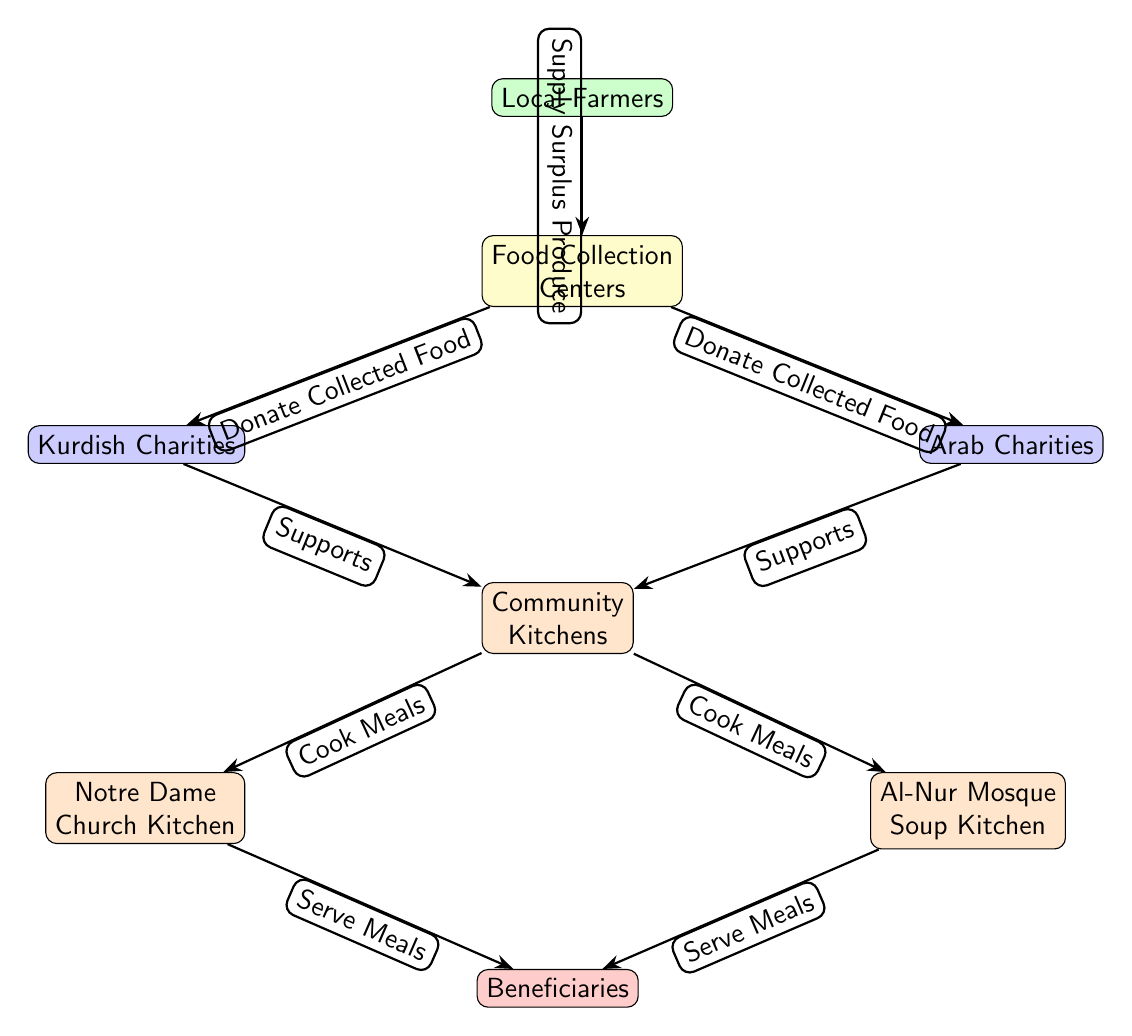What is the top node in the diagram? The top node is labeled "Local Farmers," indicating that they are the initial source of the food donation network.
Answer: Local Farmers How many community kitchens are listed in the diagram? The diagram includes two community kitchens: "Notre Dame Church Kitchen" and "Al-Nur Mosque Soup Kitchen," which are represented as child nodes of "Community Kitchens."
Answer: 2 What type of centers collect food from local farmers? The node labeled "Food Collection Centers" serves as the intermediate point where the surplus produce is collected before being donated.
Answer: Food Collection Centers Which type of charities support the community kitchens? Both "Kurdish Charities" and "Arab Charities" support the "Community Kitchens" by donating collected food, as shown in the connections on the diagram.
Answer: Kurdish Charities and Arab Charities What do community kitchens do with the donated food? The community kitchens "Cook Meals" using the food they receive from the charities, which is illustrated in the flow of the diagram.
Answer: Cook Meals How do the beneficiaries receive meals? The meals are served to the "Beneficiaries" from both the "Notre Dame Church Kitchen" and "Al-Nur Mosque Soup Kitchen," following the meals cooked in "Community Kitchens."
Answer: Serve Meals What is the relationship between Food Collection Centers and local charities? The Food Collection Centers donate collected food to both Kurdish and Arab Charities, creating a connection between these nodes.
Answer: Donate Collected Food Which community kitchen is associated with the Arab community? The "Al-Nur Mosque Soup Kitchen" is specifically linked to serving the Arab community and is one of the community kitchens listed.
Answer: Al-Nur Mosque Soup Kitchen What food source begins the donation process? The starting point of the donation process is the "Local Farmers," who supply surplus produce that initiates the food chain.
Answer: Supply Surplus Produce 